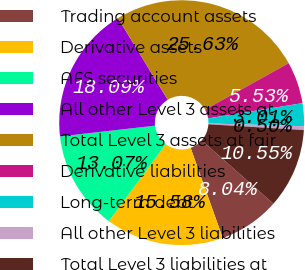<chart> <loc_0><loc_0><loc_500><loc_500><pie_chart><fcel>Trading account assets<fcel>Derivative assets<fcel>AFS securities<fcel>All other Level 3 assets at<fcel>Total Level 3 assets at fair<fcel>Derivative liabilities<fcel>Long-term debt<fcel>All other Level 3 liabilities<fcel>Total Level 3 liabilities at<nl><fcel>8.04%<fcel>15.58%<fcel>13.07%<fcel>18.09%<fcel>25.63%<fcel>5.53%<fcel>3.01%<fcel>0.5%<fcel>10.55%<nl></chart> 